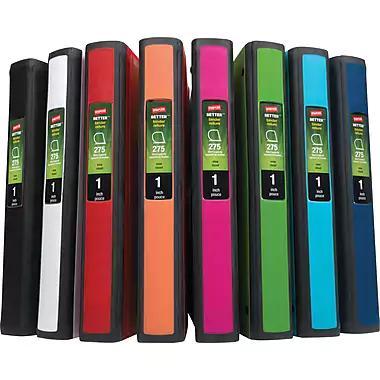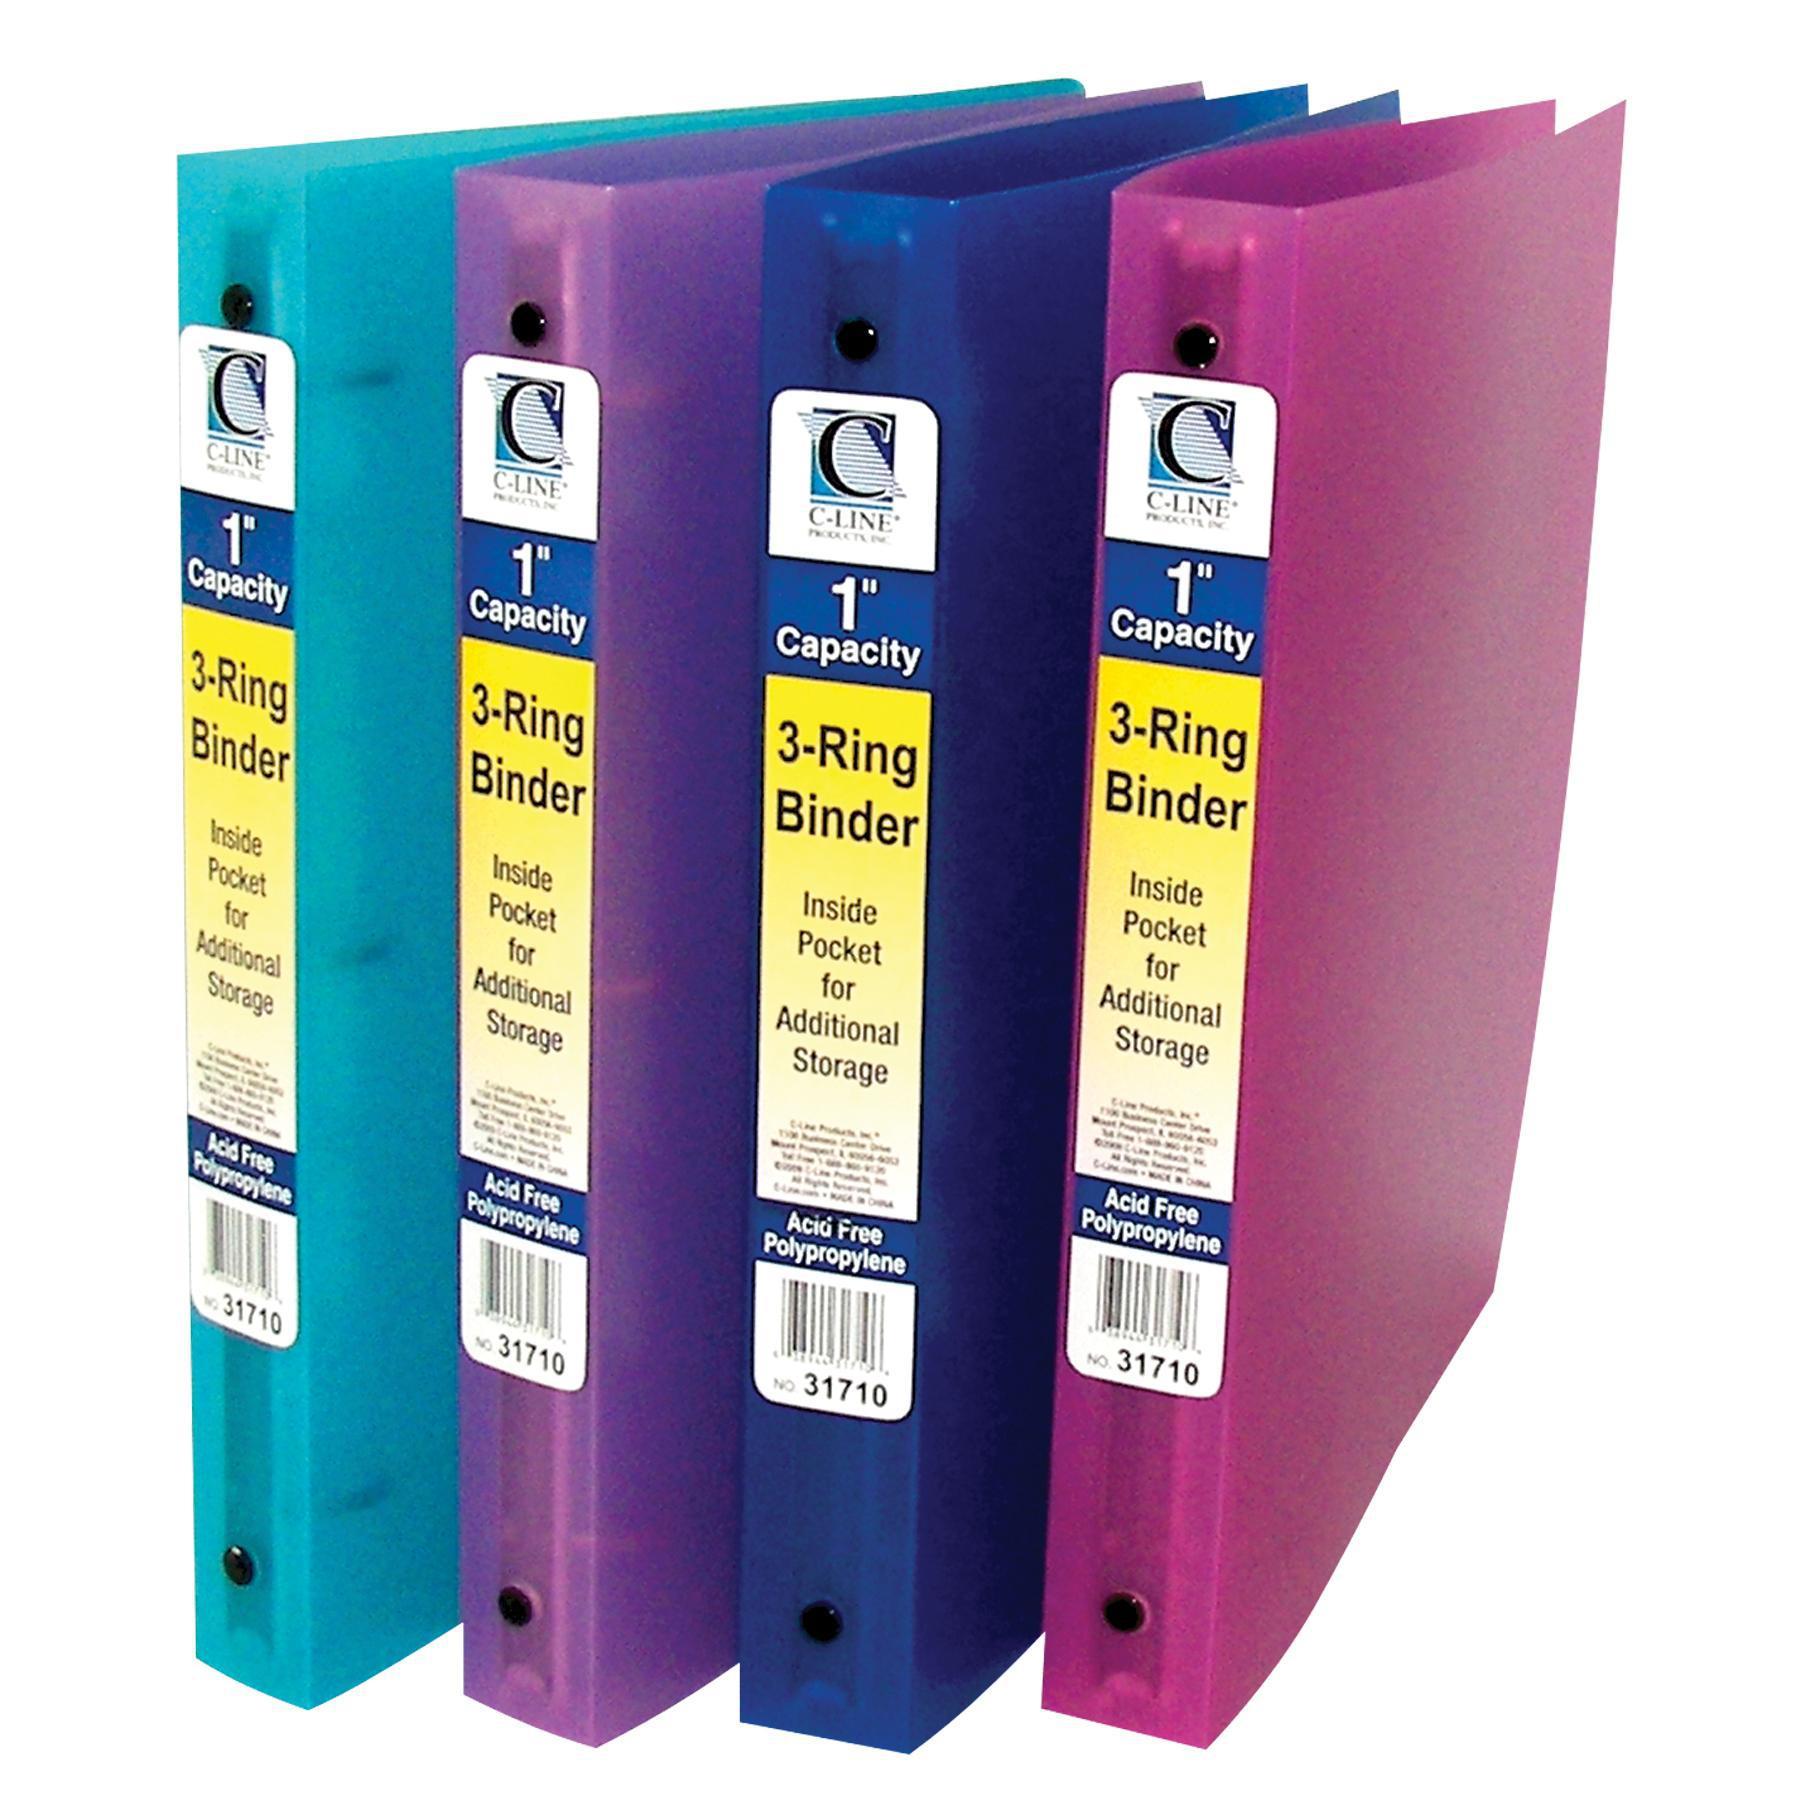The first image is the image on the left, the second image is the image on the right. Analyze the images presented: Is the assertion "There is a single binder by itself." valid? Answer yes or no. No. The first image is the image on the left, the second image is the image on the right. Analyze the images presented: Is the assertion "There are less than ten binders." valid? Answer yes or no. No. 